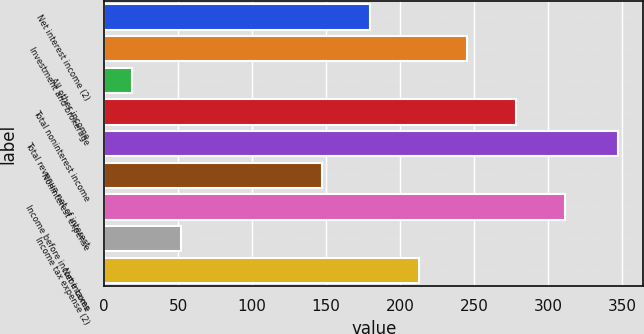<chart> <loc_0><loc_0><loc_500><loc_500><bar_chart><fcel>Net interest income (2)<fcel>Investment and brokerage<fcel>All other income<fcel>Total noninterest income<fcel>Total revenue net of interest<fcel>Noninterest expense<fcel>Income before income taxes<fcel>Income tax expense (2)<fcel>Net income<nl><fcel>179.8<fcel>245.4<fcel>19<fcel>278.2<fcel>347<fcel>147<fcel>311<fcel>51.8<fcel>212.6<nl></chart> 